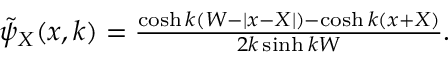<formula> <loc_0><loc_0><loc_500><loc_500>\begin{array} { r } { \tilde { \psi } _ { X } ( x , k ) = \frac { \cosh k ( W - | x - X | ) - \cosh k ( x + X ) } { 2 k \sinh k W } . } \end{array}</formula> 